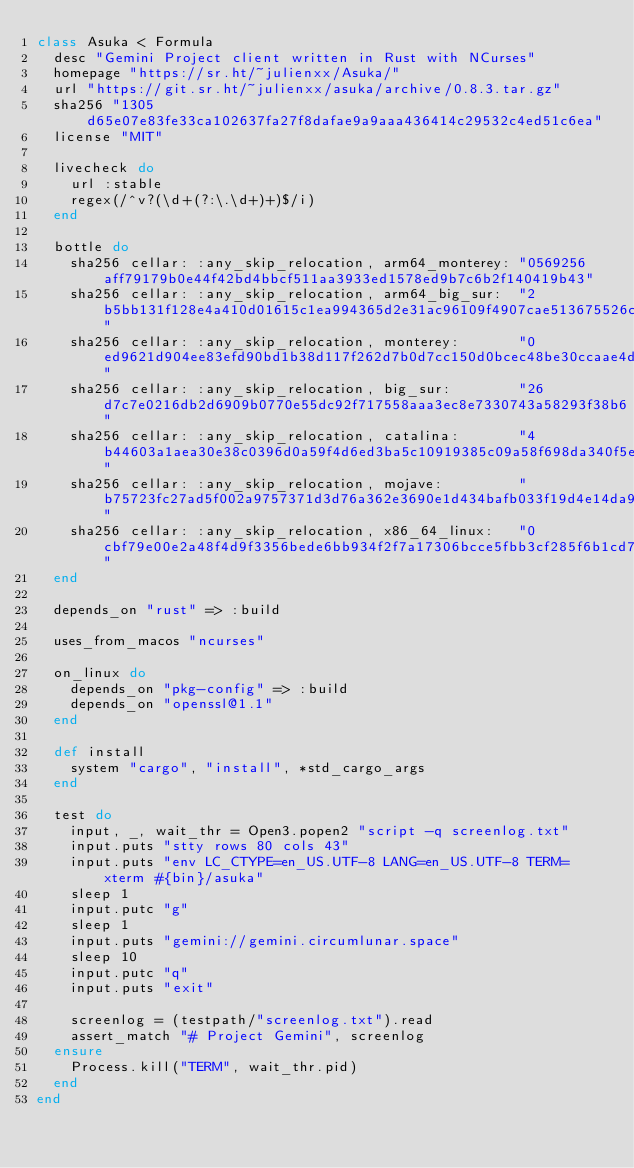<code> <loc_0><loc_0><loc_500><loc_500><_Ruby_>class Asuka < Formula
  desc "Gemini Project client written in Rust with NCurses"
  homepage "https://sr.ht/~julienxx/Asuka/"
  url "https://git.sr.ht/~julienxx/asuka/archive/0.8.3.tar.gz"
  sha256 "1305d65e07e83fe33ca102637fa27f8dafae9a9aaa436414c29532c4ed51c6ea"
  license "MIT"

  livecheck do
    url :stable
    regex(/^v?(\d+(?:\.\d+)+)$/i)
  end

  bottle do
    sha256 cellar: :any_skip_relocation, arm64_monterey: "0569256aff79179b0e44f42bd4bbcf511aa3933ed1578ed9b7c6b2f140419b43"
    sha256 cellar: :any_skip_relocation, arm64_big_sur:  "2b5bb131f128e4a410d01615c1ea994365d2e31ac96109f4907cae513675526c"
    sha256 cellar: :any_skip_relocation, monterey:       "0ed9621d904ee83efd90bd1b38d117f262d7b0d7cc150d0bcec48be30ccaae4d"
    sha256 cellar: :any_skip_relocation, big_sur:        "26d7c7e0216db2d6909b0770e55dc92f717558aaa3ec8e7330743a58293f38b6"
    sha256 cellar: :any_skip_relocation, catalina:       "4b44603a1aea30e38c0396d0a59f4d6ed3ba5c10919385c09a58f698da340f5e"
    sha256 cellar: :any_skip_relocation, mojave:         "b75723fc27ad5f002a9757371d3d76a362e3690e1d434bafb033f19d4e14da98"
    sha256 cellar: :any_skip_relocation, x86_64_linux:   "0cbf79e00e2a48f4d9f3356bede6bb934f2f7a17306bcce5fbb3cf285f6b1cd7"
  end

  depends_on "rust" => :build

  uses_from_macos "ncurses"

  on_linux do
    depends_on "pkg-config" => :build
    depends_on "openssl@1.1"
  end

  def install
    system "cargo", "install", *std_cargo_args
  end

  test do
    input, _, wait_thr = Open3.popen2 "script -q screenlog.txt"
    input.puts "stty rows 80 cols 43"
    input.puts "env LC_CTYPE=en_US.UTF-8 LANG=en_US.UTF-8 TERM=xterm #{bin}/asuka"
    sleep 1
    input.putc "g"
    sleep 1
    input.puts "gemini://gemini.circumlunar.space"
    sleep 10
    input.putc "q"
    input.puts "exit"

    screenlog = (testpath/"screenlog.txt").read
    assert_match "# Project Gemini", screenlog
  ensure
    Process.kill("TERM", wait_thr.pid)
  end
end
</code> 